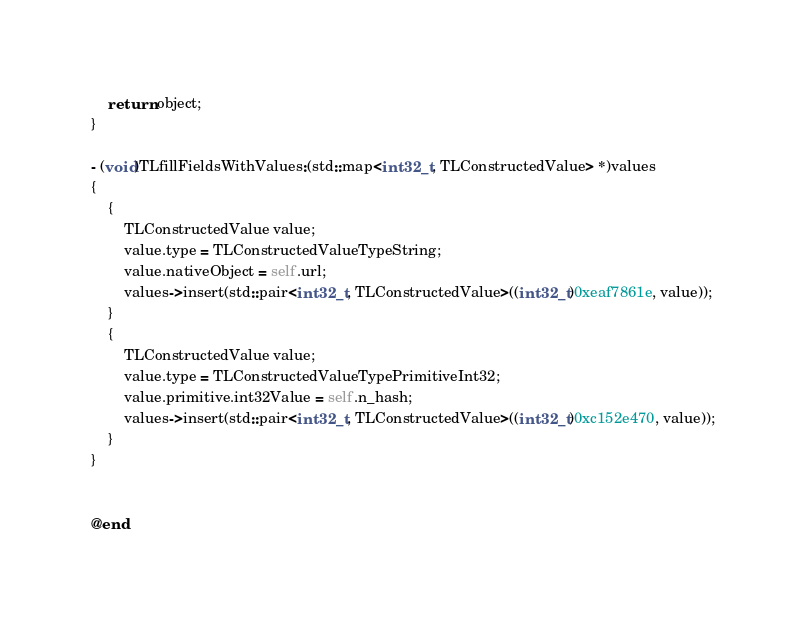Convert code to text. <code><loc_0><loc_0><loc_500><loc_500><_ObjectiveC_>    return object;
}

- (void)TLfillFieldsWithValues:(std::map<int32_t, TLConstructedValue> *)values
{
    {
        TLConstructedValue value;
        value.type = TLConstructedValueTypeString;
        value.nativeObject = self.url;
        values->insert(std::pair<int32_t, TLConstructedValue>((int32_t)0xeaf7861e, value));
    }
    {
        TLConstructedValue value;
        value.type = TLConstructedValueTypePrimitiveInt32;
        value.primitive.int32Value = self.n_hash;
        values->insert(std::pair<int32_t, TLConstructedValue>((int32_t)0xc152e470, value));
    }
}


@end

</code> 